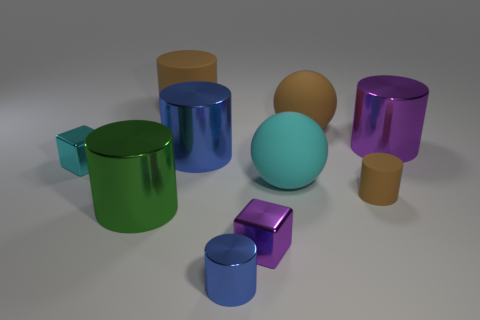How many brown cylinders must be subtracted to get 1 brown cylinders? 1 Subtract all brown spheres. How many blue cylinders are left? 2 Subtract all small cylinders. How many cylinders are left? 4 Subtract 3 cylinders. How many cylinders are left? 3 Subtract all purple cylinders. How many cylinders are left? 5 Subtract all red cylinders. Subtract all purple balls. How many cylinders are left? 6 Subtract all spheres. How many objects are left? 8 Subtract all cyan matte balls. Subtract all tiny purple cubes. How many objects are left? 8 Add 6 big brown balls. How many big brown balls are left? 7 Add 5 big purple shiny cylinders. How many big purple shiny cylinders exist? 6 